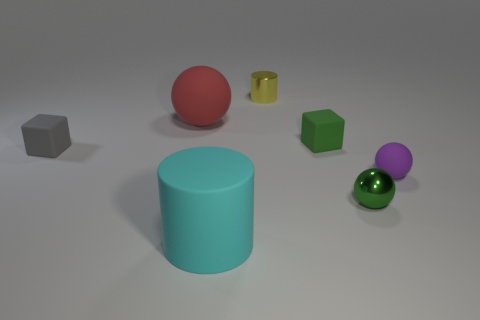Add 1 cylinders. How many objects exist? 8 Subtract all small balls. How many balls are left? 1 Subtract all green cubes. How many cubes are left? 1 Add 3 red balls. How many red balls are left? 4 Add 7 cyan matte blocks. How many cyan matte blocks exist? 7 Subtract 0 purple cylinders. How many objects are left? 7 Subtract all blocks. How many objects are left? 5 Subtract 2 cubes. How many cubes are left? 0 Subtract all gray spheres. Subtract all yellow cylinders. How many spheres are left? 3 Subtract all matte things. Subtract all large rubber objects. How many objects are left? 0 